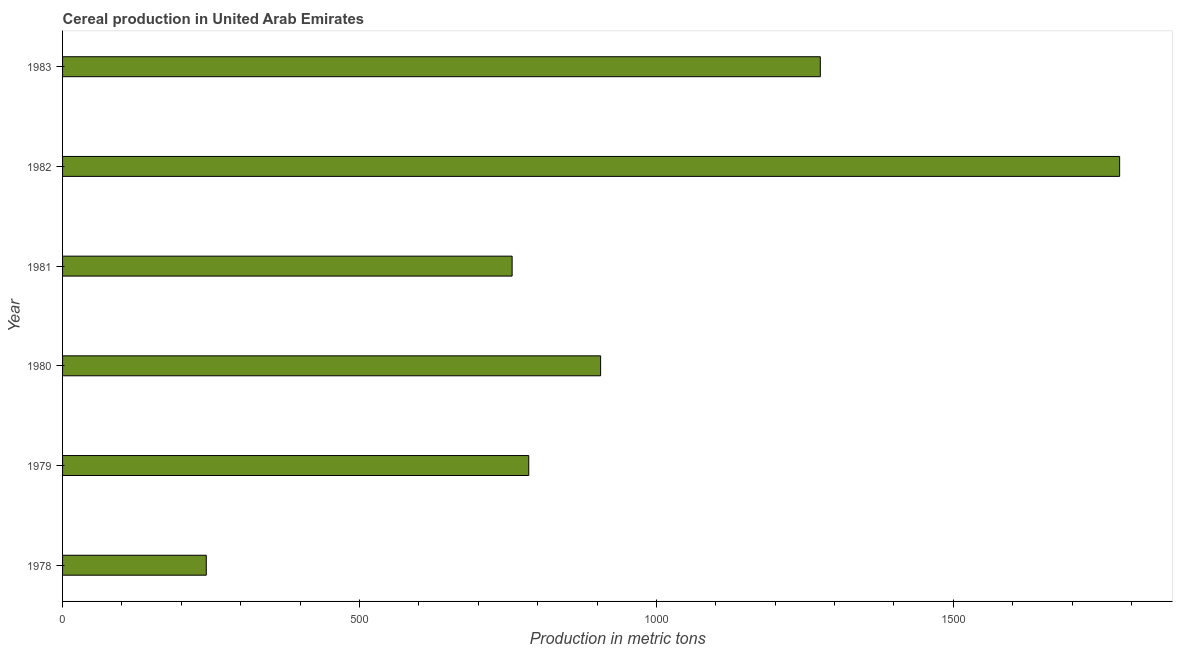Does the graph contain any zero values?
Give a very brief answer. No. Does the graph contain grids?
Keep it short and to the point. No. What is the title of the graph?
Your answer should be compact. Cereal production in United Arab Emirates. What is the label or title of the X-axis?
Offer a terse response. Production in metric tons. What is the label or title of the Y-axis?
Ensure brevity in your answer.  Year. What is the cereal production in 1981?
Make the answer very short. 757. Across all years, what is the maximum cereal production?
Your response must be concise. 1780. Across all years, what is the minimum cereal production?
Your answer should be very brief. 242. In which year was the cereal production maximum?
Your answer should be compact. 1982. In which year was the cereal production minimum?
Provide a short and direct response. 1978. What is the sum of the cereal production?
Make the answer very short. 5746. What is the difference between the cereal production in 1981 and 1983?
Your answer should be very brief. -519. What is the average cereal production per year?
Give a very brief answer. 957. What is the median cereal production?
Your response must be concise. 845.5. What is the ratio of the cereal production in 1980 to that in 1982?
Ensure brevity in your answer.  0.51. Is the cereal production in 1981 less than that in 1983?
Keep it short and to the point. Yes. Is the difference between the cereal production in 1978 and 1983 greater than the difference between any two years?
Keep it short and to the point. No. What is the difference between the highest and the second highest cereal production?
Provide a succinct answer. 504. What is the difference between the highest and the lowest cereal production?
Provide a succinct answer. 1538. In how many years, is the cereal production greater than the average cereal production taken over all years?
Ensure brevity in your answer.  2. Are all the bars in the graph horizontal?
Your answer should be very brief. Yes. How many years are there in the graph?
Ensure brevity in your answer.  6. Are the values on the major ticks of X-axis written in scientific E-notation?
Give a very brief answer. No. What is the Production in metric tons in 1978?
Offer a terse response. 242. What is the Production in metric tons in 1979?
Your response must be concise. 785. What is the Production in metric tons of 1980?
Your response must be concise. 906. What is the Production in metric tons in 1981?
Provide a succinct answer. 757. What is the Production in metric tons in 1982?
Your answer should be very brief. 1780. What is the Production in metric tons of 1983?
Give a very brief answer. 1276. What is the difference between the Production in metric tons in 1978 and 1979?
Give a very brief answer. -543. What is the difference between the Production in metric tons in 1978 and 1980?
Provide a short and direct response. -664. What is the difference between the Production in metric tons in 1978 and 1981?
Provide a succinct answer. -515. What is the difference between the Production in metric tons in 1978 and 1982?
Your answer should be compact. -1538. What is the difference between the Production in metric tons in 1978 and 1983?
Your response must be concise. -1034. What is the difference between the Production in metric tons in 1979 and 1980?
Your answer should be compact. -121. What is the difference between the Production in metric tons in 1979 and 1981?
Offer a terse response. 28. What is the difference between the Production in metric tons in 1979 and 1982?
Give a very brief answer. -995. What is the difference between the Production in metric tons in 1979 and 1983?
Provide a short and direct response. -491. What is the difference between the Production in metric tons in 1980 and 1981?
Offer a very short reply. 149. What is the difference between the Production in metric tons in 1980 and 1982?
Keep it short and to the point. -874. What is the difference between the Production in metric tons in 1980 and 1983?
Your answer should be very brief. -370. What is the difference between the Production in metric tons in 1981 and 1982?
Your answer should be compact. -1023. What is the difference between the Production in metric tons in 1981 and 1983?
Your answer should be compact. -519. What is the difference between the Production in metric tons in 1982 and 1983?
Offer a terse response. 504. What is the ratio of the Production in metric tons in 1978 to that in 1979?
Offer a terse response. 0.31. What is the ratio of the Production in metric tons in 1978 to that in 1980?
Ensure brevity in your answer.  0.27. What is the ratio of the Production in metric tons in 1978 to that in 1981?
Make the answer very short. 0.32. What is the ratio of the Production in metric tons in 1978 to that in 1982?
Give a very brief answer. 0.14. What is the ratio of the Production in metric tons in 1978 to that in 1983?
Ensure brevity in your answer.  0.19. What is the ratio of the Production in metric tons in 1979 to that in 1980?
Your response must be concise. 0.87. What is the ratio of the Production in metric tons in 1979 to that in 1982?
Provide a succinct answer. 0.44. What is the ratio of the Production in metric tons in 1979 to that in 1983?
Provide a succinct answer. 0.61. What is the ratio of the Production in metric tons in 1980 to that in 1981?
Your answer should be compact. 1.2. What is the ratio of the Production in metric tons in 1980 to that in 1982?
Provide a succinct answer. 0.51. What is the ratio of the Production in metric tons in 1980 to that in 1983?
Offer a very short reply. 0.71. What is the ratio of the Production in metric tons in 1981 to that in 1982?
Provide a succinct answer. 0.42. What is the ratio of the Production in metric tons in 1981 to that in 1983?
Offer a terse response. 0.59. What is the ratio of the Production in metric tons in 1982 to that in 1983?
Your answer should be very brief. 1.4. 